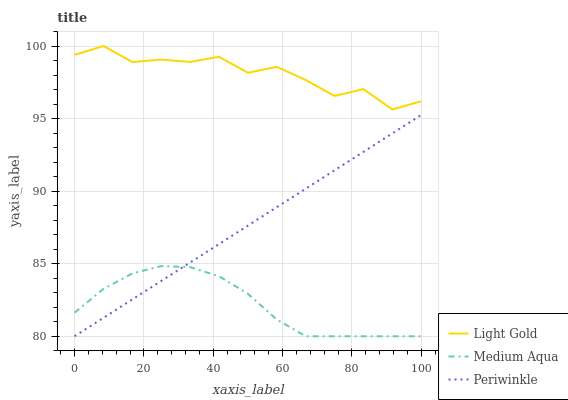Does Medium Aqua have the minimum area under the curve?
Answer yes or no. Yes. Does Light Gold have the maximum area under the curve?
Answer yes or no. Yes. Does Periwinkle have the minimum area under the curve?
Answer yes or no. No. Does Periwinkle have the maximum area under the curve?
Answer yes or no. No. Is Periwinkle the smoothest?
Answer yes or no. Yes. Is Light Gold the roughest?
Answer yes or no. Yes. Is Light Gold the smoothest?
Answer yes or no. No. Is Periwinkle the roughest?
Answer yes or no. No. Does Light Gold have the lowest value?
Answer yes or no. No. Does Light Gold have the highest value?
Answer yes or no. Yes. Does Periwinkle have the highest value?
Answer yes or no. No. Is Medium Aqua less than Light Gold?
Answer yes or no. Yes. Is Light Gold greater than Periwinkle?
Answer yes or no. Yes. Does Periwinkle intersect Medium Aqua?
Answer yes or no. Yes. Is Periwinkle less than Medium Aqua?
Answer yes or no. No. Is Periwinkle greater than Medium Aqua?
Answer yes or no. No. Does Medium Aqua intersect Light Gold?
Answer yes or no. No. 